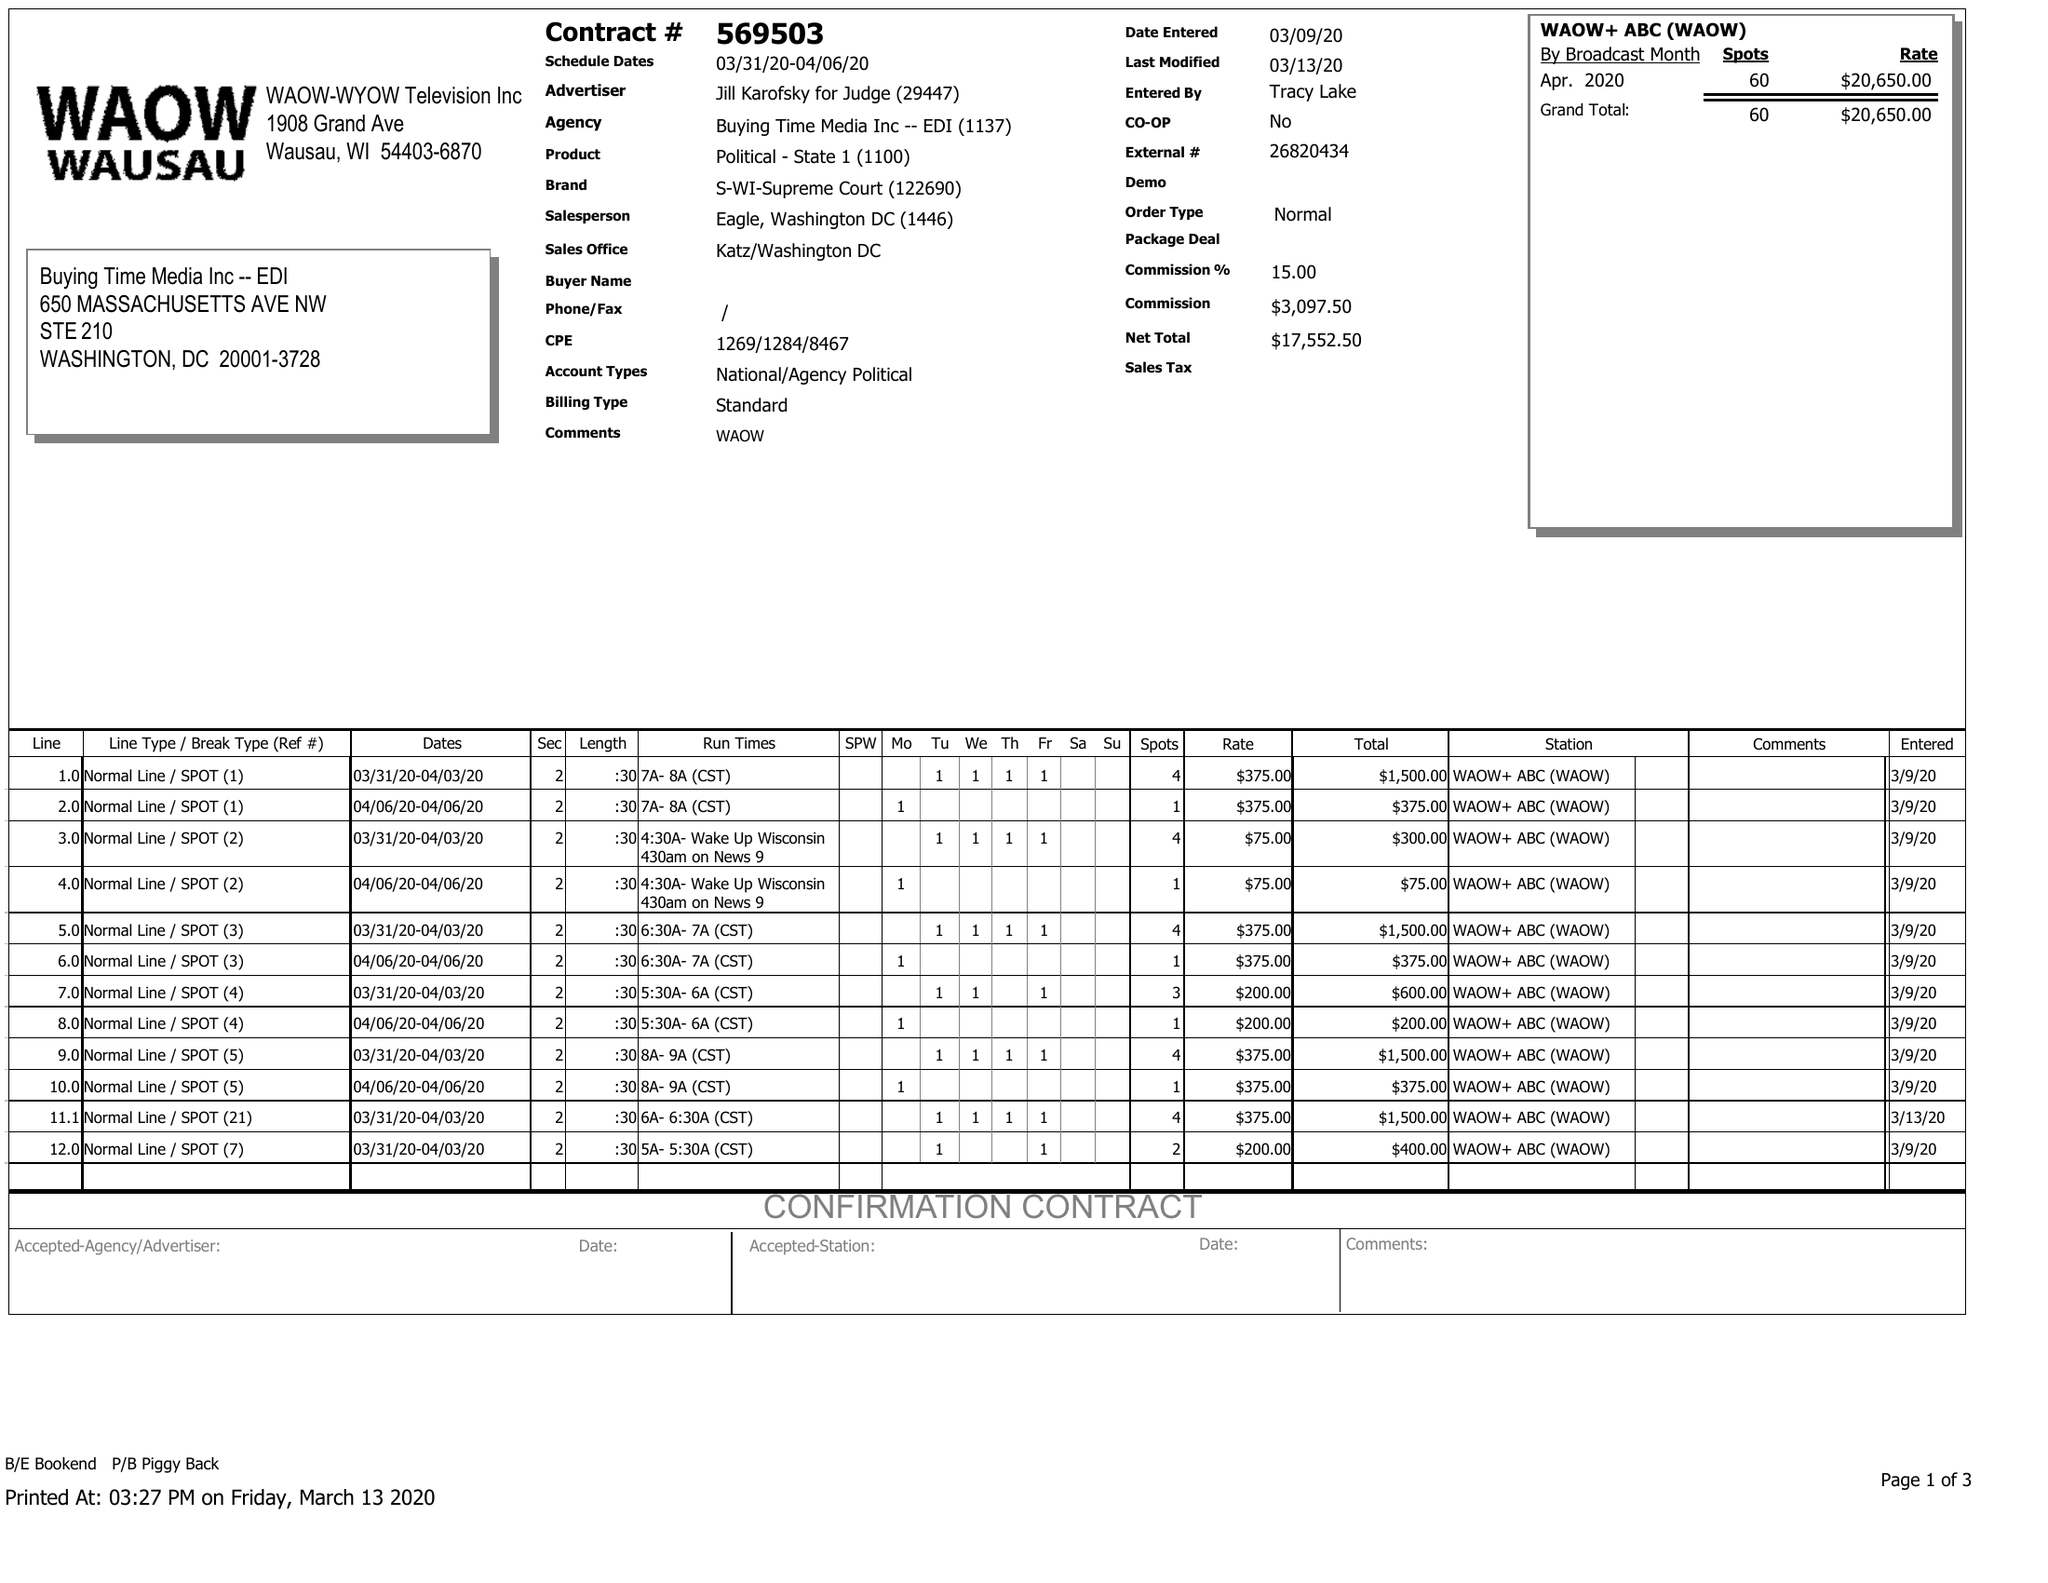What is the value for the flight_from?
Answer the question using a single word or phrase. 03/31/20 